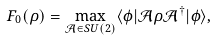<formula> <loc_0><loc_0><loc_500><loc_500>F _ { 0 } ( \rho ) = \max _ { \mathcal { A } \in S U ( 2 ) } \langle \phi | \mathcal { A } \rho \mathcal { A } ^ { \dagger } | \phi \rangle ,</formula> 